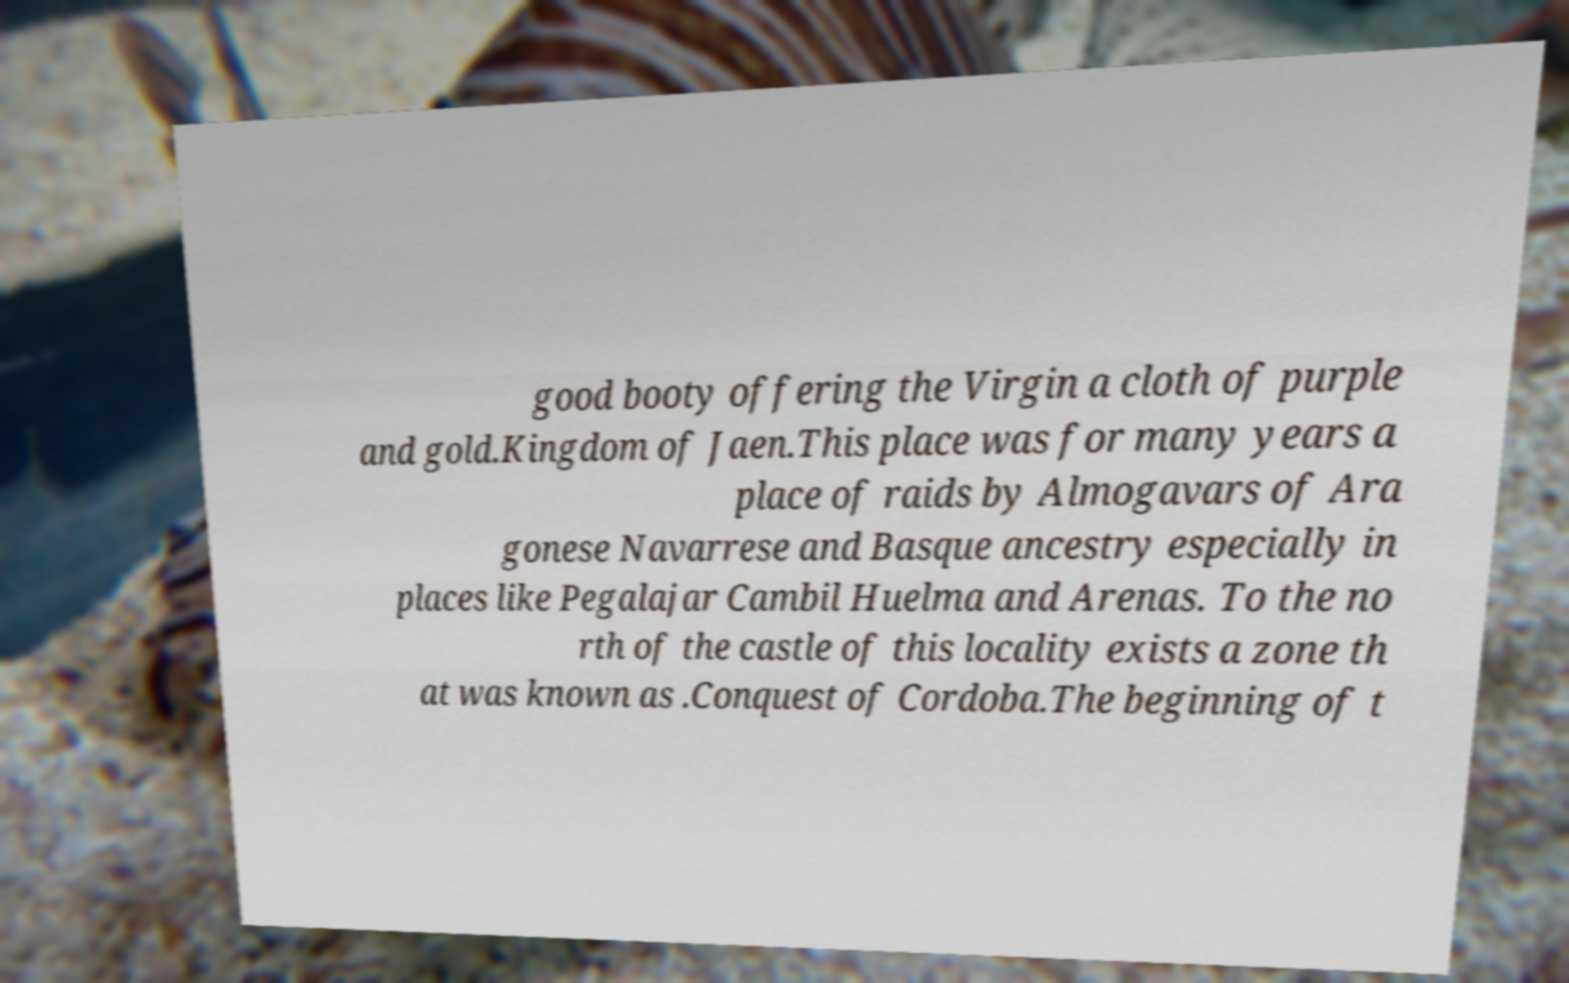Could you extract and type out the text from this image? good booty offering the Virgin a cloth of purple and gold.Kingdom of Jaen.This place was for many years a place of raids by Almogavars of Ara gonese Navarrese and Basque ancestry especially in places like Pegalajar Cambil Huelma and Arenas. To the no rth of the castle of this locality exists a zone th at was known as .Conquest of Cordoba.The beginning of t 